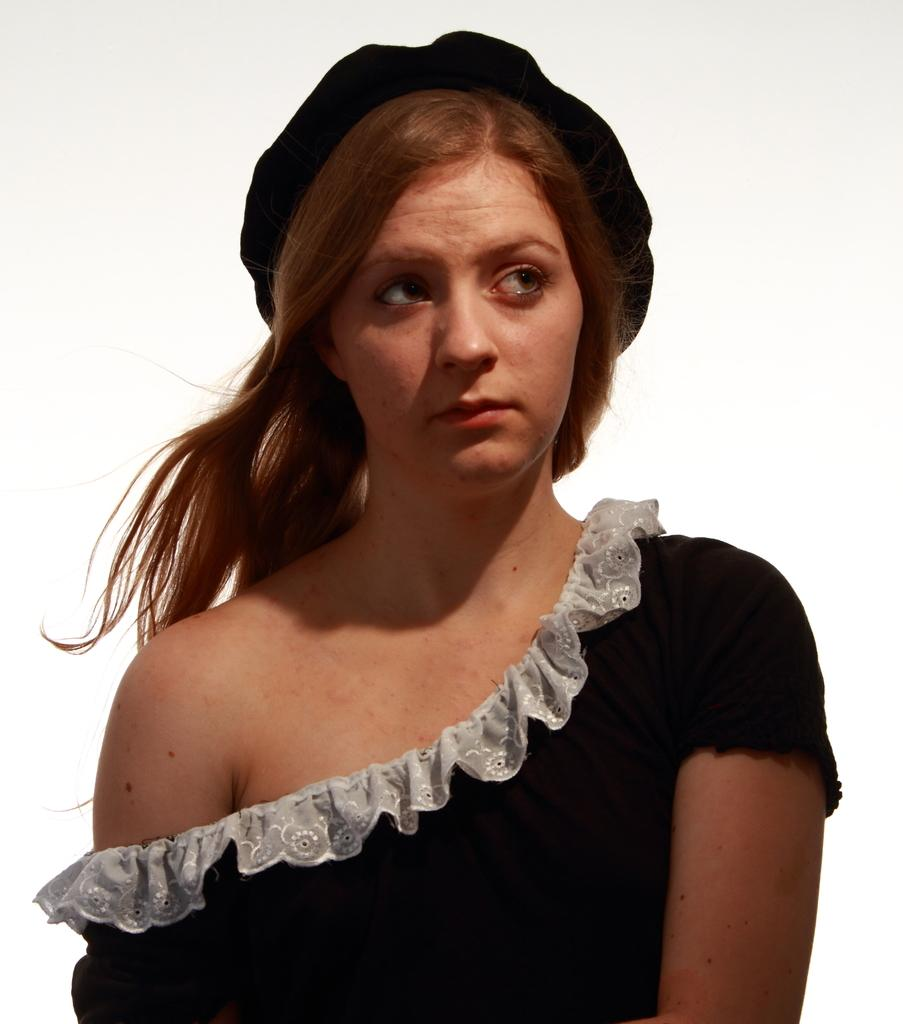Who is present in the image? There is a woman in the image. What can be seen in the background of the image? The background of the image is white. How many birds are sitting on the woman's elbow in the image? There are no birds present in the image, and therefore no birds are sitting on the woman's elbow. 